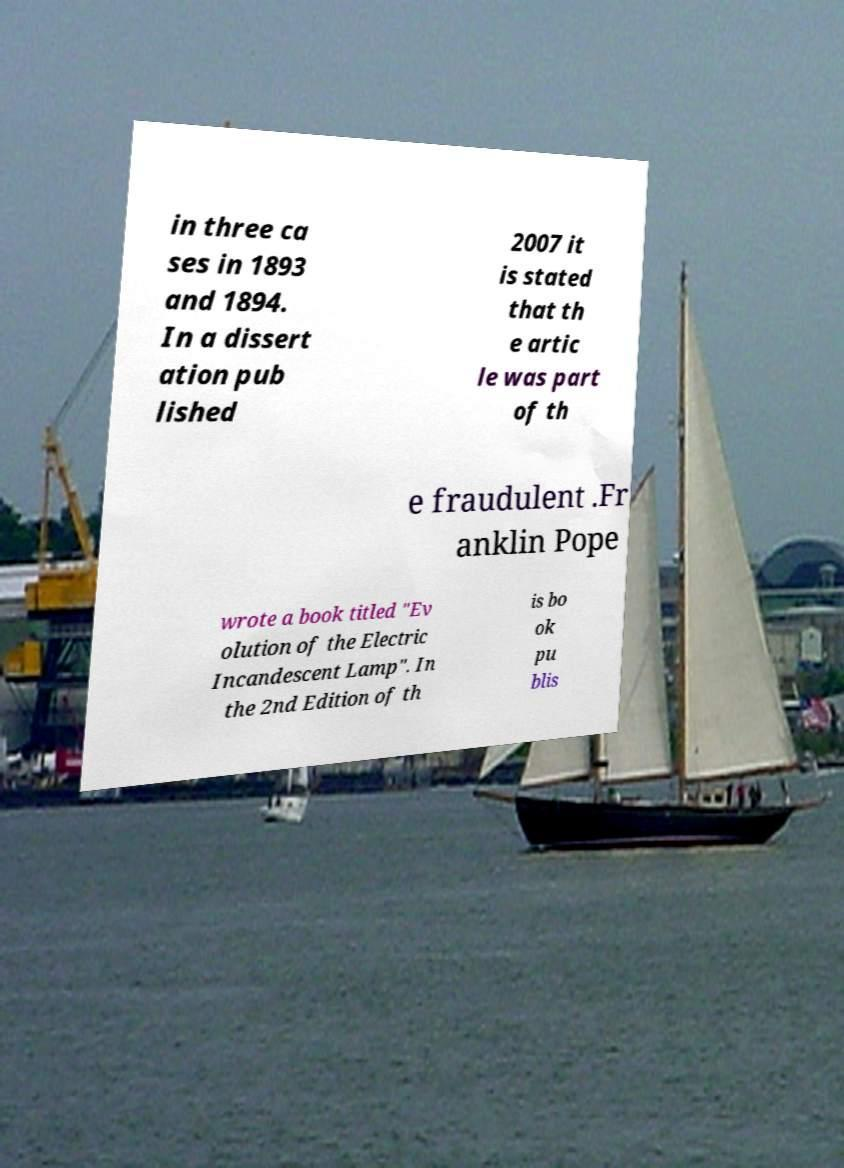Could you assist in decoding the text presented in this image and type it out clearly? in three ca ses in 1893 and 1894. In a dissert ation pub lished 2007 it is stated that th e artic le was part of th e fraudulent .Fr anklin Pope wrote a book titled "Ev olution of the Electric Incandescent Lamp". In the 2nd Edition of th is bo ok pu blis 